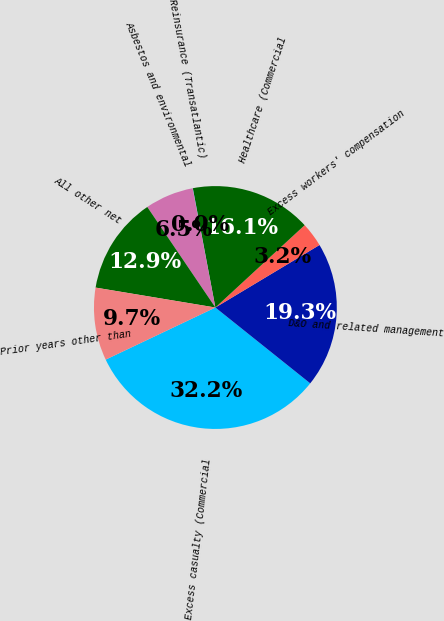<chart> <loc_0><loc_0><loc_500><loc_500><pie_chart><fcel>Excess casualty (Commercial<fcel>D&O and related management<fcel>Excess workers' compensation<fcel>Healthcare (Commercial<fcel>Reinsurance (Transatlantic)<fcel>Asbestos and environmental<fcel>All other net<fcel>Prior years other than<nl><fcel>32.21%<fcel>19.34%<fcel>3.25%<fcel>16.12%<fcel>0.03%<fcel>6.47%<fcel>12.9%<fcel>9.68%<nl></chart> 